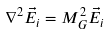Convert formula to latex. <formula><loc_0><loc_0><loc_500><loc_500>\nabla ^ { 2 } \vec { E } _ { i } = M _ { G } ^ { 2 } \vec { E } _ { i }</formula> 